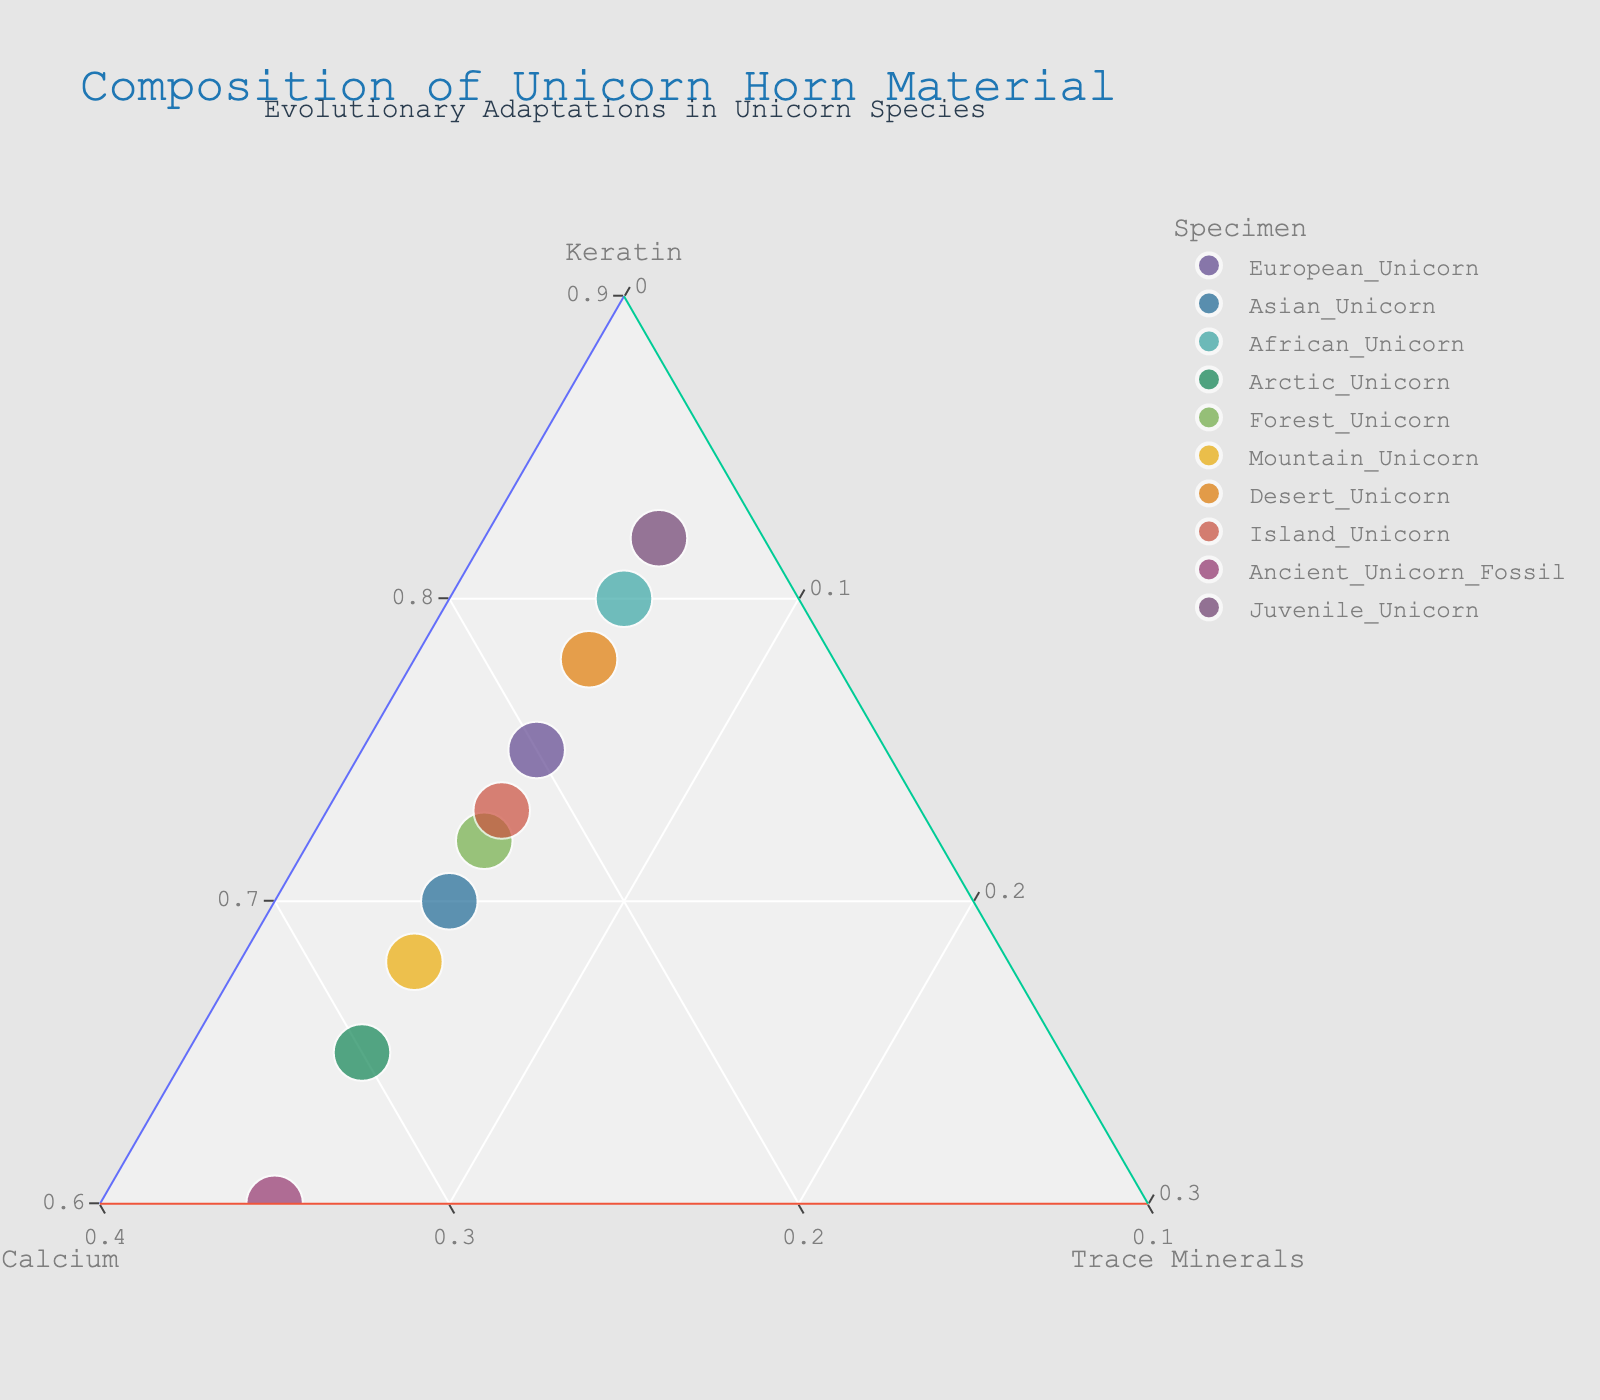What's the title of the figure? The title is typically located at the top of the figure. In this case, the title is clearly visible and reads "Composition of Unicorn Horn Material".
Answer: Composition of Unicorn Horn Material Which unicorn species has the highest proportion of keratin? We look for the data point closest to the "Keratin" axis. The Juvenile Unicorn, positioned closest to this axis, has the highest proportion of keratin.
Answer: Juvenile Unicorn How many distinct unicorn species are represented in the plot? The number of data points, each labeled with a unique species name, determines the number of distinct species. There are 10 distinct data points.
Answer: 10 Which unicorn has the smallest proportion of calcium? We locate the data point closest to the "Keratin" and "Trace Minerals" axes, furthest from the "Calcium" axis. The Juvenile Unicorn is closest to these axes, indicating it has the smallest proportion of calcium.
Answer: Juvenile Unicorn Compare the keratin content between the European Unicorn and the Arctic Unicorn. Which one has a higher proportion? By comparing their positions relative to the "Keratin" axis, the European Unicorn is closer, meaning it has a higher keratin proportion than the Arctic Unicorn.
Answer: European Unicorn Is there any unicorn species with the same proportion of trace minerals? By locating the "Trace Minerals" axis, we see that all data points are aligned at the same level, indicating each species has the same proportion of 5%.
Answer: Yes What is the average proportion of calcium among the European Unicorn, Asian Unicorn, and African Unicorn? Summing their calcium proportions: 20% (European) + 25% (Asian) + 15% (African) = 60%. Dividing by 3 gives the average: 60% / 3 = 20%.
Answer: 20% Which two unicorns have calcium proportions that differ by exactly 10%? By inspecting the calcium proportions, African Unicorn (15%) and Mountain Unicorn (27%) show a difference of 10%.
Answer: African Unicorn and Mountain Unicorn Which unicorn species shows the most balanced composition of horn material? The most balanced composition is indicated by a point closest to the center of the plot. The Forest Unicorn, positioned near the center, represents the most balanced composition.
Answer: Forest Unicorn 